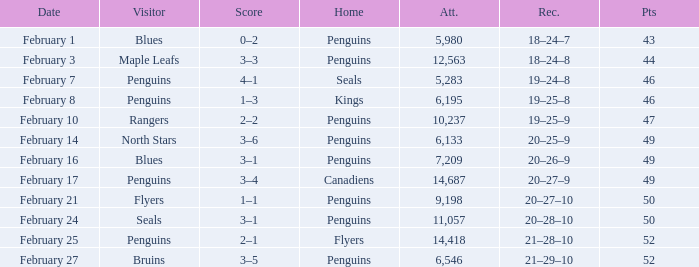Would you mind parsing the complete table? {'header': ['Date', 'Visitor', 'Score', 'Home', 'Att.', 'Rec.', 'Pts'], 'rows': [['February 1', 'Blues', '0–2', 'Penguins', '5,980', '18–24–7', '43'], ['February 3', 'Maple Leafs', '3–3', 'Penguins', '12,563', '18–24–8', '44'], ['February 7', 'Penguins', '4–1', 'Seals', '5,283', '19–24–8', '46'], ['February 8', 'Penguins', '1–3', 'Kings', '6,195', '19–25–8', '46'], ['February 10', 'Rangers', '2–2', 'Penguins', '10,237', '19–25–9', '47'], ['February 14', 'North Stars', '3–6', 'Penguins', '6,133', '20–25–9', '49'], ['February 16', 'Blues', '3–1', 'Penguins', '7,209', '20–26–9', '49'], ['February 17', 'Penguins', '3–4', 'Canadiens', '14,687', '20–27–9', '49'], ['February 21', 'Flyers', '1–1', 'Penguins', '9,198', '20–27–10', '50'], ['February 24', 'Seals', '3–1', 'Penguins', '11,057', '20–28–10', '50'], ['February 25', 'Penguins', '2–1', 'Flyers', '14,418', '21–28–10', '52'], ['February 27', 'Bruins', '3–5', 'Penguins', '6,546', '21–29–10', '52']]} Home of kings had what score? 1–3. 